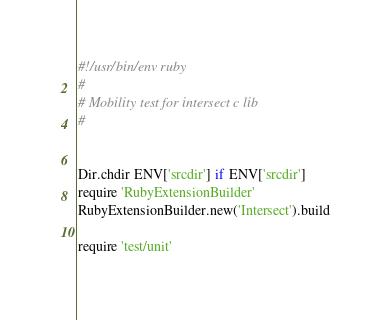Convert code to text. <code><loc_0><loc_0><loc_500><loc_500><_Ruby_>#!/usr/bin/env ruby
#
# Mobility test for intersect c lib
#


Dir.chdir ENV['srcdir'] if ENV['srcdir']
require 'RubyExtensionBuilder'
RubyExtensionBuilder.new('Intersect').build

require 'test/unit'</code> 